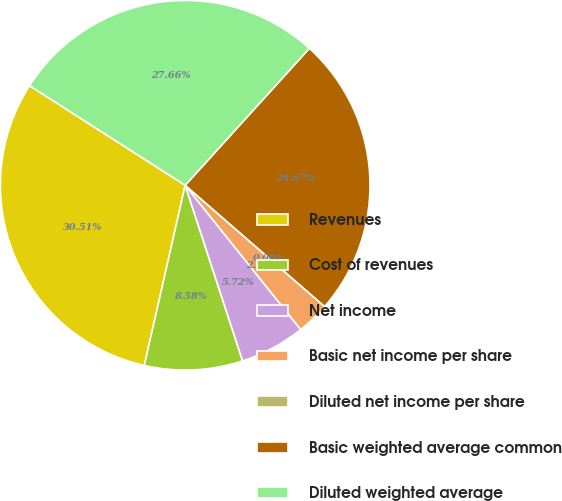Convert chart to OTSL. <chart><loc_0><loc_0><loc_500><loc_500><pie_chart><fcel>Revenues<fcel>Cost of revenues<fcel>Net income<fcel>Basic net income per share<fcel>Diluted net income per share<fcel>Basic weighted average common<fcel>Diluted weighted average<nl><fcel>30.51%<fcel>8.58%<fcel>5.72%<fcel>2.86%<fcel>0.0%<fcel>24.67%<fcel>27.66%<nl></chart> 